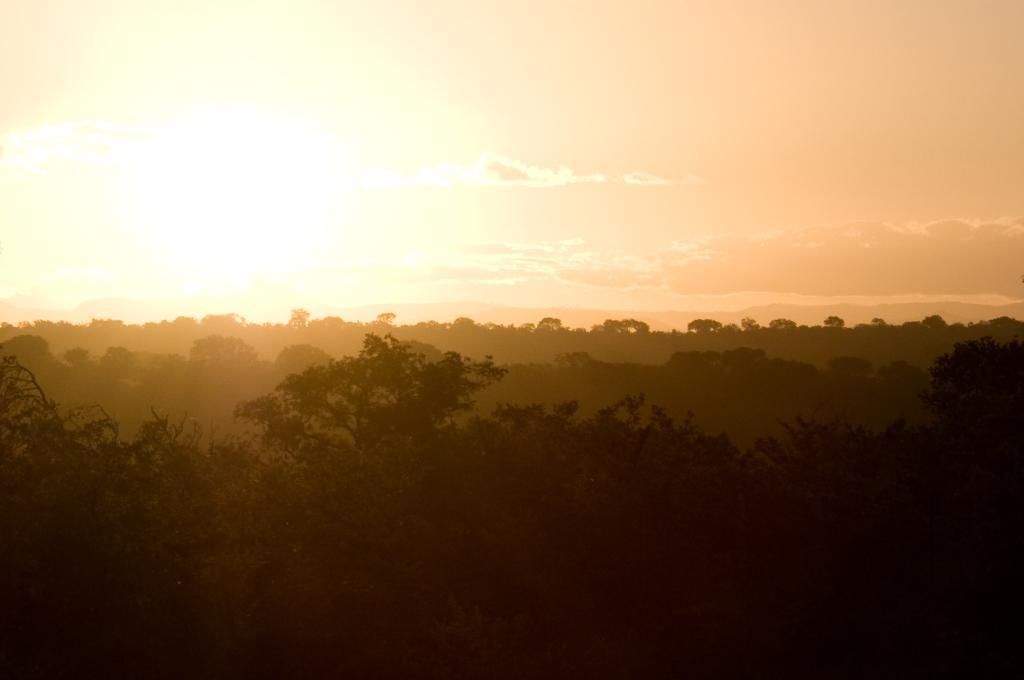What type of natural elements can be seen in the image? There are trees and clouds visible in the image. What part of the natural environment is visible in the image? The sky is visible in the image. What is the color of the sky in the image? The color of the sky is orange in the image. How would you describe the lighting in the image? The image appears to be slightly dark. How many lizards can be seen crawling on the trees in the image? There are no lizards present in the image; it only features trees, clouds, and an orange sky. 